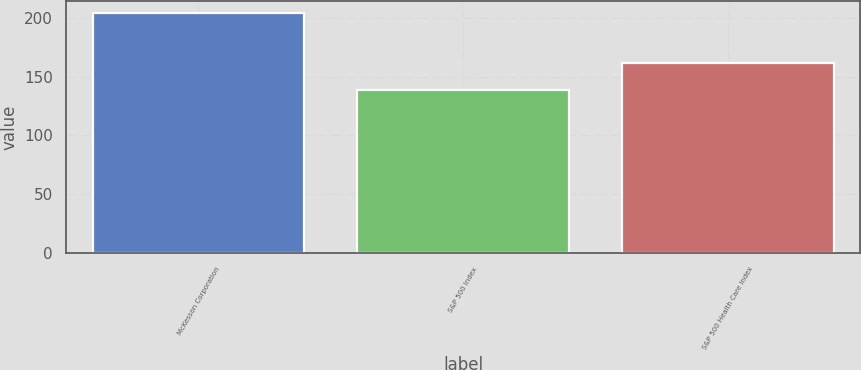<chart> <loc_0><loc_0><loc_500><loc_500><bar_chart><fcel>McKesson Corporation<fcel>S&P 500 Index<fcel>S&P 500 Health Care Index<nl><fcel>204.26<fcel>138.87<fcel>161.79<nl></chart> 